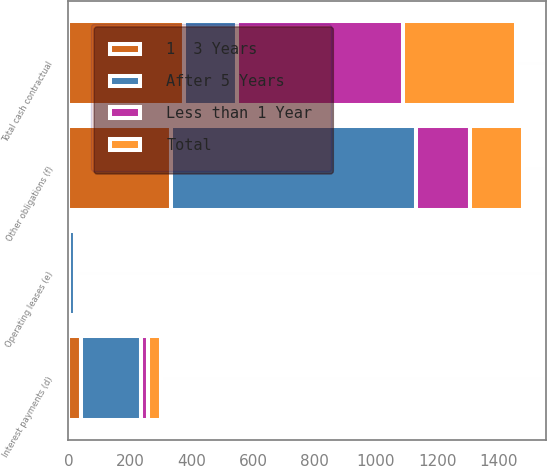Convert chart to OTSL. <chart><loc_0><loc_0><loc_500><loc_500><stacked_bar_chart><ecel><fcel>Interest payments (d)<fcel>Operating leases (e)<fcel>Other obligations (f)<fcel>Total cash contractual<nl><fcel>After 5 Years<fcel>195<fcel>18<fcel>797<fcel>171<nl><fcel>Less than 1 Year<fcel>21<fcel>1<fcel>178<fcel>541<nl><fcel>1  3 Years<fcel>42<fcel>3<fcel>332<fcel>377<nl><fcel>Total<fcel>42<fcel>2<fcel>171<fcel>366<nl></chart> 